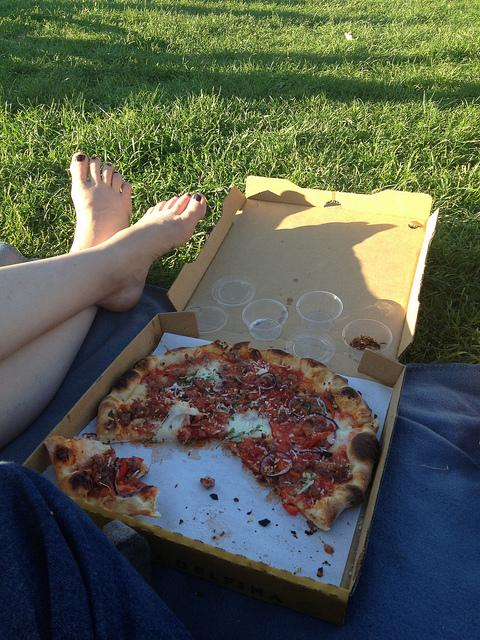What is the proper name for this style of eating? picnic 